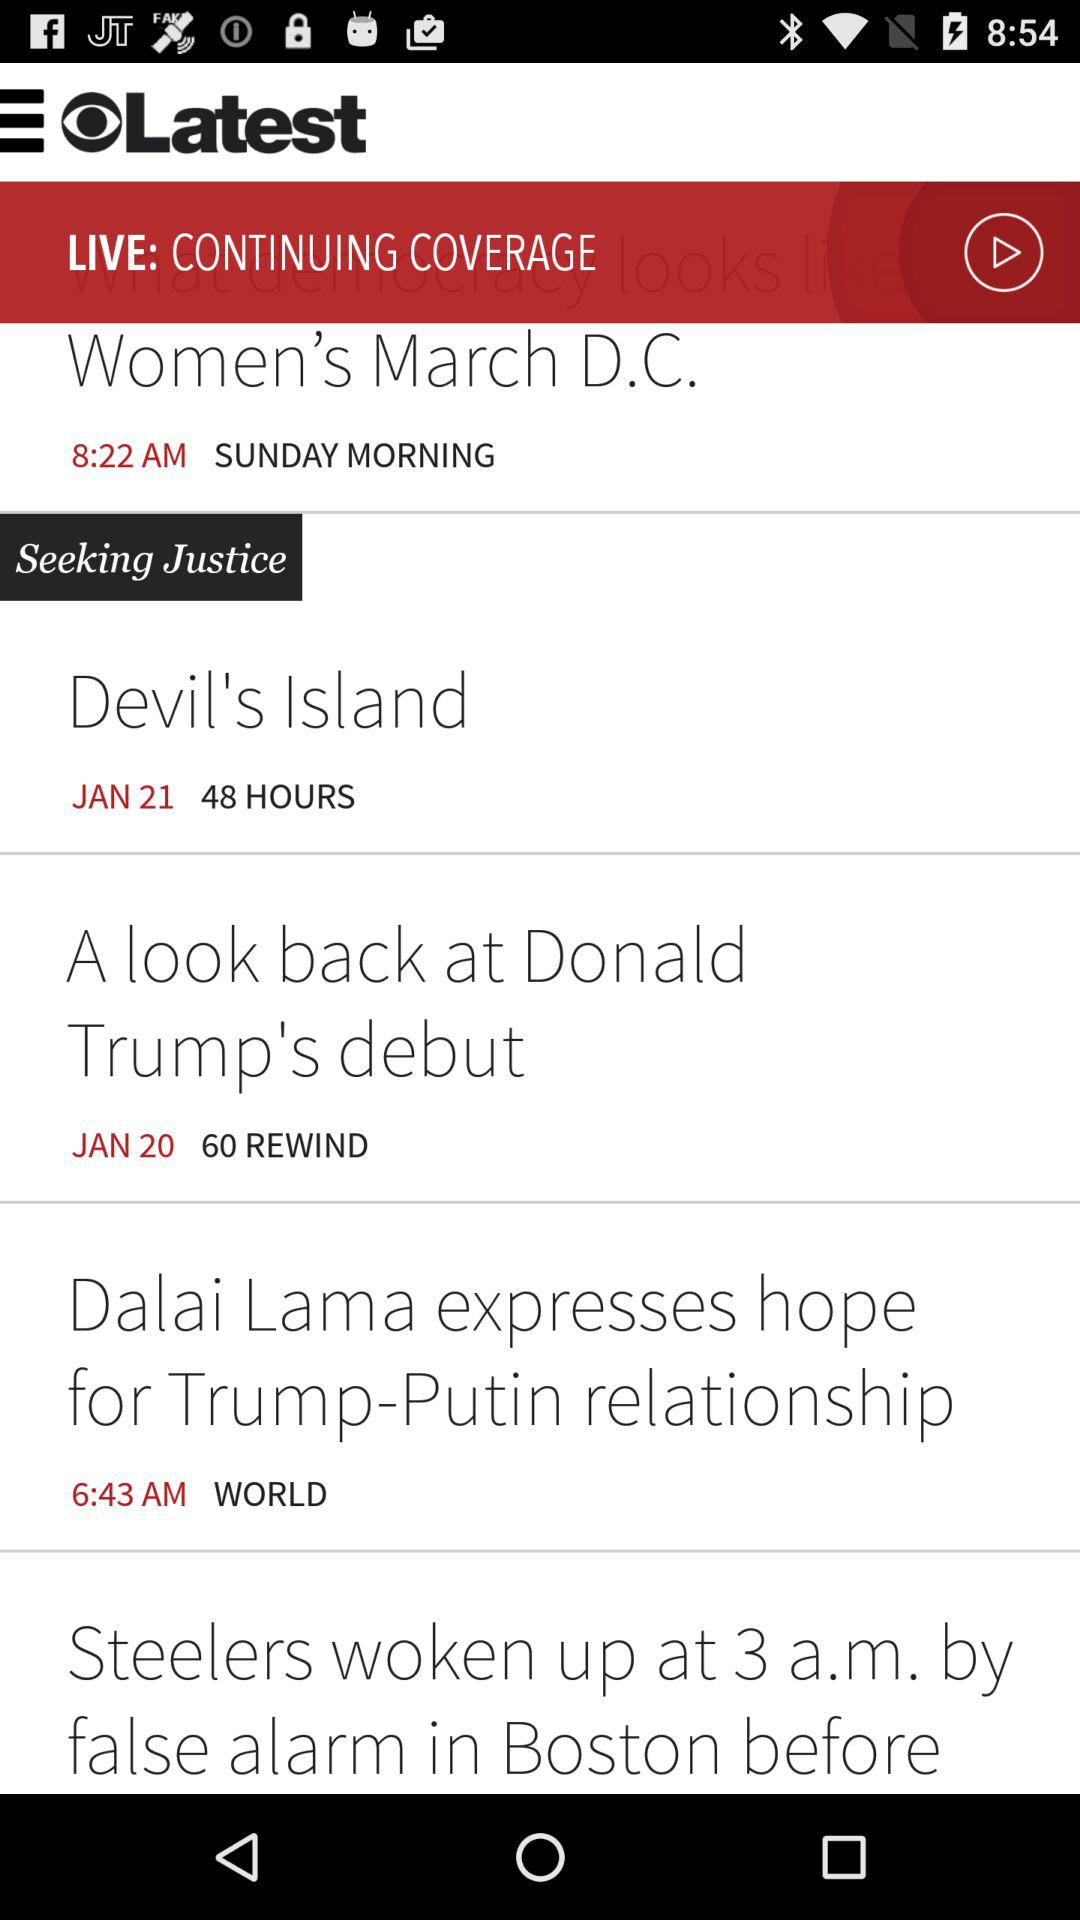How many rewinds are there on "A look back at Donald Trump's debut"? There are 60 rewinds. 